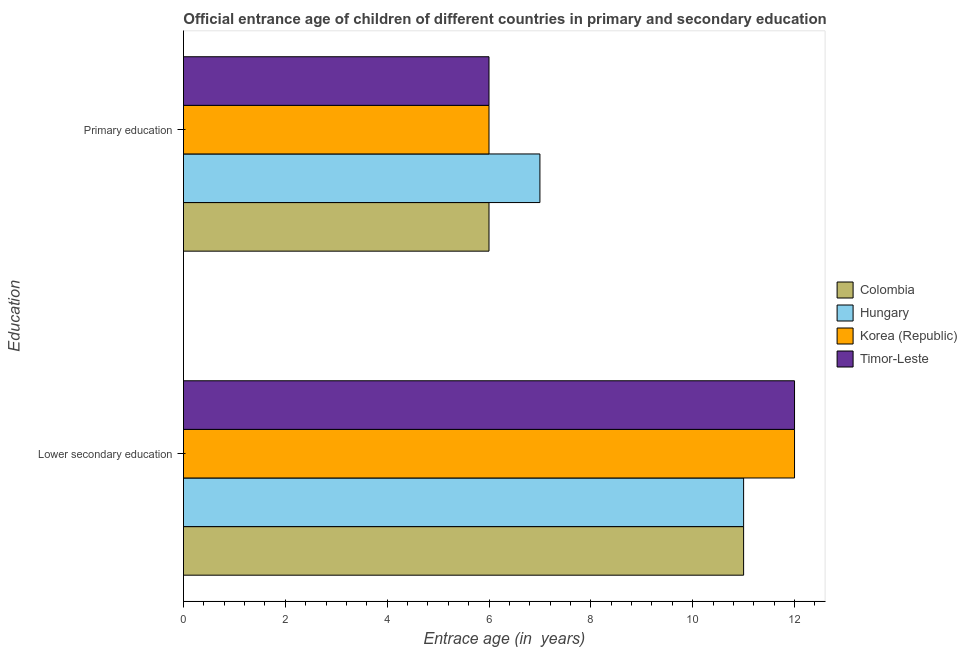Are the number of bars on each tick of the Y-axis equal?
Your answer should be very brief. Yes. How many bars are there on the 2nd tick from the top?
Give a very brief answer. 4. How many bars are there on the 1st tick from the bottom?
Make the answer very short. 4. What is the label of the 2nd group of bars from the top?
Provide a succinct answer. Lower secondary education. What is the entrance age of children in lower secondary education in Colombia?
Offer a very short reply. 11. Across all countries, what is the maximum entrance age of children in lower secondary education?
Your answer should be compact. 12. Across all countries, what is the minimum entrance age of children in lower secondary education?
Provide a short and direct response. 11. In which country was the entrance age of chiildren in primary education minimum?
Make the answer very short. Colombia. What is the total entrance age of children in lower secondary education in the graph?
Provide a short and direct response. 46. What is the difference between the entrance age of children in lower secondary education in Timor-Leste and that in Colombia?
Make the answer very short. 1. What is the difference between the entrance age of children in lower secondary education in Hungary and the entrance age of chiildren in primary education in Colombia?
Offer a very short reply. 5. What is the average entrance age of chiildren in primary education per country?
Your response must be concise. 6.25. What is the difference between the entrance age of children in lower secondary education and entrance age of chiildren in primary education in Colombia?
Offer a terse response. 5. In how many countries, is the entrance age of chiildren in primary education greater than 7.6 years?
Your response must be concise. 0. What is the ratio of the entrance age of children in lower secondary education in Timor-Leste to that in Hungary?
Offer a terse response. 1.09. In how many countries, is the entrance age of chiildren in primary education greater than the average entrance age of chiildren in primary education taken over all countries?
Your response must be concise. 1. What does the 1st bar from the top in Lower secondary education represents?
Ensure brevity in your answer.  Timor-Leste. What does the 4th bar from the bottom in Primary education represents?
Provide a short and direct response. Timor-Leste. How many bars are there?
Your answer should be very brief. 8. How many countries are there in the graph?
Your answer should be compact. 4. Are the values on the major ticks of X-axis written in scientific E-notation?
Make the answer very short. No. Does the graph contain any zero values?
Give a very brief answer. No. Where does the legend appear in the graph?
Your answer should be compact. Center right. How many legend labels are there?
Make the answer very short. 4. What is the title of the graph?
Give a very brief answer. Official entrance age of children of different countries in primary and secondary education. Does "Uganda" appear as one of the legend labels in the graph?
Make the answer very short. No. What is the label or title of the X-axis?
Your answer should be compact. Entrace age (in  years). What is the label or title of the Y-axis?
Offer a terse response. Education. What is the Entrace age (in  years) of Timor-Leste in Lower secondary education?
Keep it short and to the point. 12. What is the Entrace age (in  years) in Colombia in Primary education?
Make the answer very short. 6. What is the Entrace age (in  years) in Hungary in Primary education?
Give a very brief answer. 7. What is the Entrace age (in  years) in Korea (Republic) in Primary education?
Offer a terse response. 6. Across all Education, what is the maximum Entrace age (in  years) in Colombia?
Your answer should be compact. 11. Across all Education, what is the maximum Entrace age (in  years) in Hungary?
Provide a short and direct response. 11. Across all Education, what is the maximum Entrace age (in  years) in Korea (Republic)?
Ensure brevity in your answer.  12. Across all Education, what is the maximum Entrace age (in  years) in Timor-Leste?
Your response must be concise. 12. Across all Education, what is the minimum Entrace age (in  years) in Colombia?
Keep it short and to the point. 6. Across all Education, what is the minimum Entrace age (in  years) of Hungary?
Provide a succinct answer. 7. What is the total Entrace age (in  years) of Colombia in the graph?
Provide a short and direct response. 17. What is the total Entrace age (in  years) in Hungary in the graph?
Provide a succinct answer. 18. What is the total Entrace age (in  years) of Korea (Republic) in the graph?
Offer a terse response. 18. What is the difference between the Entrace age (in  years) of Colombia in Lower secondary education and that in Primary education?
Your answer should be very brief. 5. What is the difference between the Entrace age (in  years) in Hungary in Lower secondary education and that in Primary education?
Provide a short and direct response. 4. What is the difference between the Entrace age (in  years) in Korea (Republic) in Lower secondary education and that in Primary education?
Offer a terse response. 6. What is the difference between the Entrace age (in  years) in Timor-Leste in Lower secondary education and that in Primary education?
Ensure brevity in your answer.  6. What is the difference between the Entrace age (in  years) in Colombia in Lower secondary education and the Entrace age (in  years) in Korea (Republic) in Primary education?
Your answer should be compact. 5. What is the difference between the Entrace age (in  years) of Hungary in Lower secondary education and the Entrace age (in  years) of Timor-Leste in Primary education?
Provide a short and direct response. 5. What is the difference between the Entrace age (in  years) of Korea (Republic) in Lower secondary education and the Entrace age (in  years) of Timor-Leste in Primary education?
Keep it short and to the point. 6. What is the average Entrace age (in  years) of Korea (Republic) per Education?
Make the answer very short. 9. What is the average Entrace age (in  years) of Timor-Leste per Education?
Provide a short and direct response. 9. What is the difference between the Entrace age (in  years) of Colombia and Entrace age (in  years) of Timor-Leste in Lower secondary education?
Provide a succinct answer. -1. What is the difference between the Entrace age (in  years) in Hungary and Entrace age (in  years) in Timor-Leste in Lower secondary education?
Your answer should be very brief. -1. What is the difference between the Entrace age (in  years) of Korea (Republic) and Entrace age (in  years) of Timor-Leste in Lower secondary education?
Provide a succinct answer. 0. What is the difference between the Entrace age (in  years) of Colombia and Entrace age (in  years) of Hungary in Primary education?
Keep it short and to the point. -1. What is the difference between the Entrace age (in  years) of Colombia and Entrace age (in  years) of Korea (Republic) in Primary education?
Your answer should be very brief. 0. What is the difference between the Entrace age (in  years) in Colombia and Entrace age (in  years) in Timor-Leste in Primary education?
Give a very brief answer. 0. What is the difference between the Entrace age (in  years) of Korea (Republic) and Entrace age (in  years) of Timor-Leste in Primary education?
Your answer should be very brief. 0. What is the ratio of the Entrace age (in  years) in Colombia in Lower secondary education to that in Primary education?
Your answer should be compact. 1.83. What is the ratio of the Entrace age (in  years) in Hungary in Lower secondary education to that in Primary education?
Offer a very short reply. 1.57. What is the ratio of the Entrace age (in  years) of Korea (Republic) in Lower secondary education to that in Primary education?
Your answer should be very brief. 2. What is the ratio of the Entrace age (in  years) of Timor-Leste in Lower secondary education to that in Primary education?
Offer a terse response. 2. What is the difference between the highest and the second highest Entrace age (in  years) in Hungary?
Your answer should be very brief. 4. What is the difference between the highest and the lowest Entrace age (in  years) in Hungary?
Offer a terse response. 4. What is the difference between the highest and the lowest Entrace age (in  years) in Timor-Leste?
Your answer should be compact. 6. 